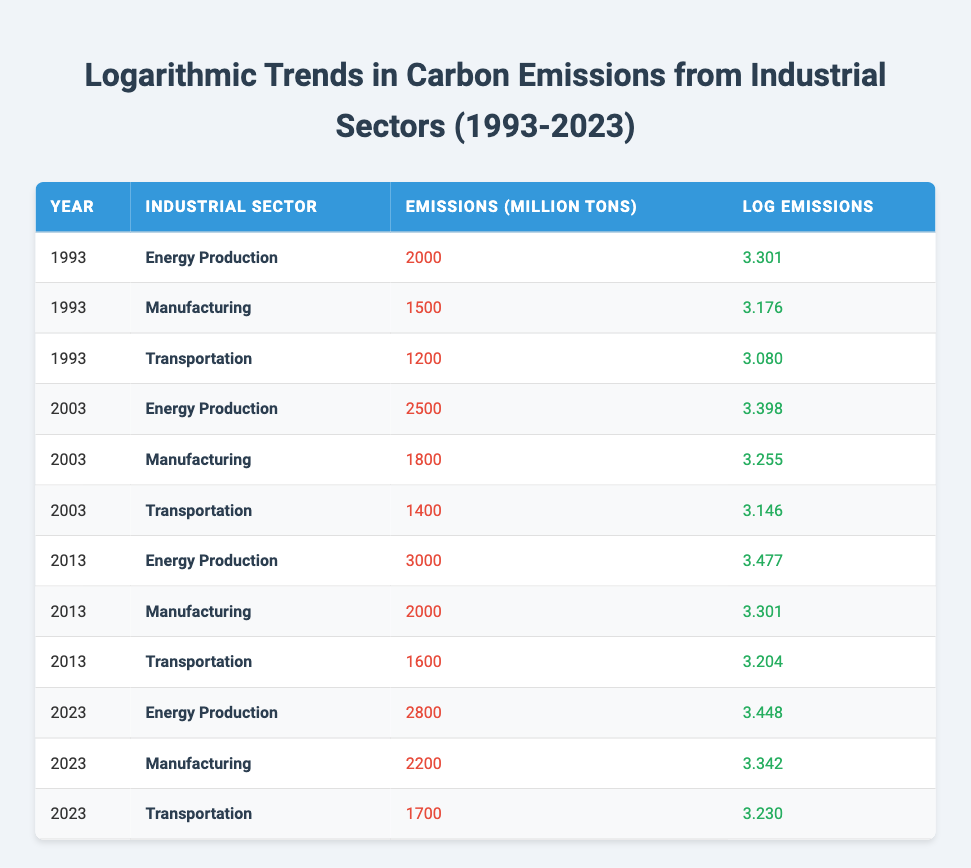What were the carbon emissions from the Energy Production sector in 2013? From the table, the row corresponding to the year 2013 and the Energy Production sector shows emissions of 3000 million tons.
Answer: 3000 What is the logarithmic value of emissions for the Transportation sector in 2003? Referring to the table, the Transportation sector in the year 2003 has a logarithmic value of emissions listed as 3.146.
Answer: 3.146 Which industrial sector had the highest emissions in 2023? The table indicates that in 2023, the Energy Production sector had the highest emissions at 2800 million tons when compared to Transportation (1700 million tons) and Manufacturing (2200 million tons).
Answer: Energy Production What was the total carbon emissions for the Manufacturing sector from 1993 to 2023? Adding the emissions from the Manufacturing sector across the years: 1500 (1993) + 1800 (2003) + 2000 (2013) + 2200 (2023) = 9500 million tons.
Answer: 9500 Is there an increase in carbon emissions from the Energy Production sector from 2003 to 2023? Comparing the emissions, Energy Production had 2500 million tons in 2003 and 2800 million tons in 2023. This shows an increase of 300 million tons. Therefore, the statement is true.
Answer: Yes What is the average logarithmic value of emissions across all sectors in 2013? The logarithmic values for 2013 are: 3.477 (Energy Production), 3.301 (Manufacturing), and 3.204 (Transportation). The average is (3.477 + 3.301 + 3.204) / 3 = 3.32733, approximately 3.33.
Answer: 3.33 Did the Manufacturing sector have higher logarithmic emissions in 2023 compared to 2013? The logarithmic emissions for Manufacturing in 2023 is 3.342, while in 2013 it was 3.301. Since 3.342 > 3.301, the statement is true.
Answer: Yes What was the percentage increase in emissions from Energy Production between 2003 and 2013? The figures for these years show emissions of 2500 million tons in 2003 and 3000 million tons in 2013. The increase is (3000 - 2500) = 500 million tons. The percentage increase is (500/2500) * 100 = 20%.
Answer: 20% Which sector showed the least increase in emissions from 2003 to 2023? Evaluating the increases: Energy Production (2500 to 2800 = 300), Manufacturing (1800 to 2200 = 400), and Transportation (1400 to 1700 = 300). Both Energy Production and Transportation had the least increase of 300 million tons.
Answer: Energy Production and Transportation 